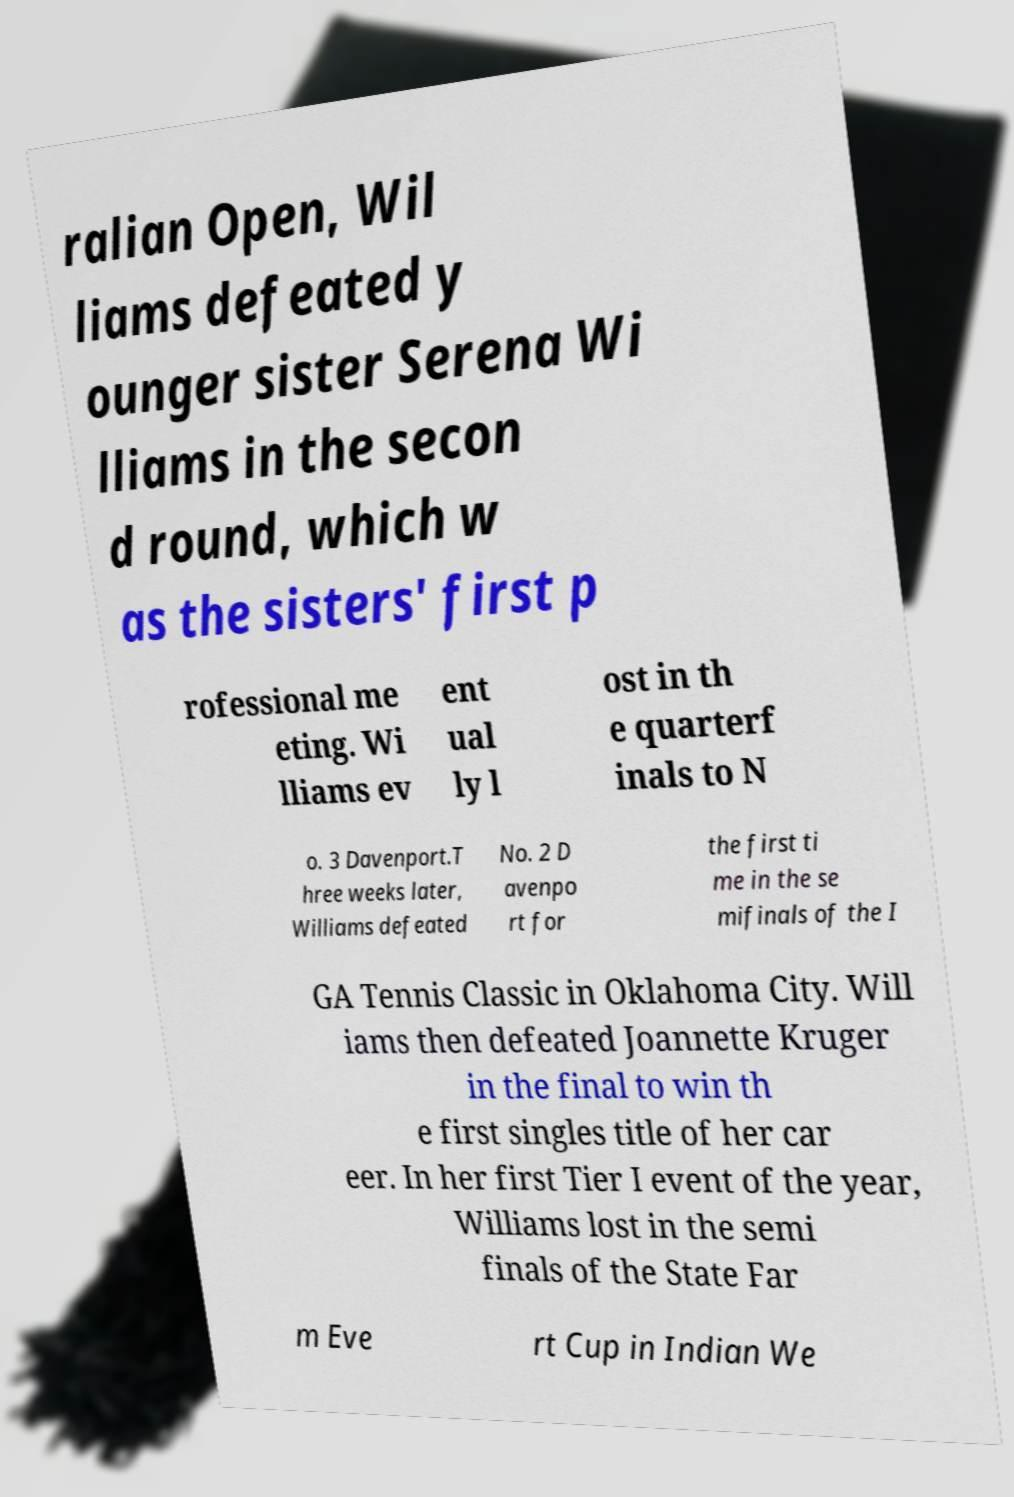Can you read and provide the text displayed in the image?This photo seems to have some interesting text. Can you extract and type it out for me? ralian Open, Wil liams defeated y ounger sister Serena Wi lliams in the secon d round, which w as the sisters' first p rofessional me eting. Wi lliams ev ent ual ly l ost in th e quarterf inals to N o. 3 Davenport.T hree weeks later, Williams defeated No. 2 D avenpo rt for the first ti me in the se mifinals of the I GA Tennis Classic in Oklahoma City. Will iams then defeated Joannette Kruger in the final to win th e first singles title of her car eer. In her first Tier I event of the year, Williams lost in the semi finals of the State Far m Eve rt Cup in Indian We 